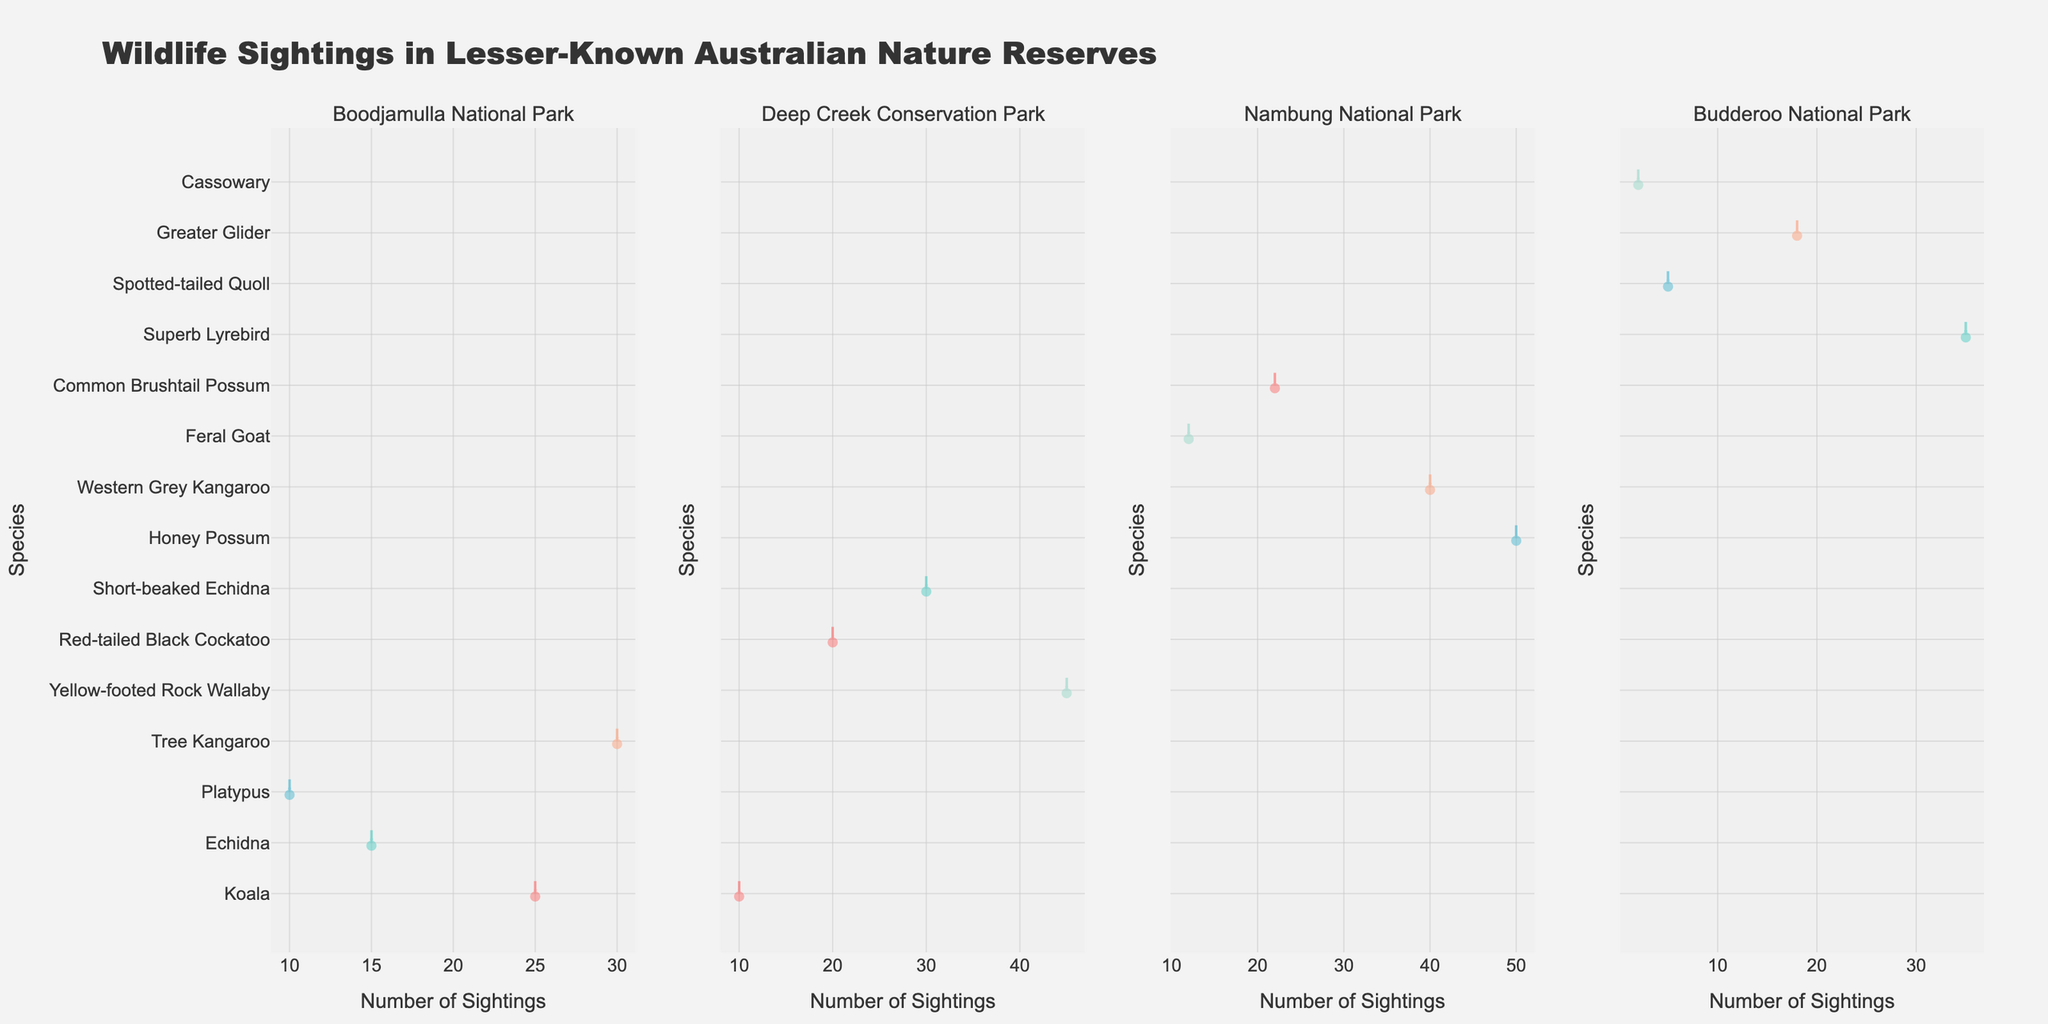What is the title of the plot? The title of the plot is written at the top and it summarizes the content of the figure.
Answer: "Wildlife Sightings in Lesser-Known Australian Nature Reserves" Which nature reserve shows the highest number of Koala sightings? To identify this, look at the violin plots for Koala sightings across all the reserve subplots. Then, check which reserve has the longest spread or highest peak.
Answer: Boodjamulla National Park What is the total number of Echidna sightings across all nature reserves? Sum the individual sightings of Echidnas displayed in each subplot for Boodjamulla National Park and Deep Creek Conservation Park. For Boodjamulla, it's 15 sightings, and for Deep Creek, it's 30 sightings. The total is 15 + 30.
Answer: 45 How do the sighting numbers of the Yellow-footed Rock Wallaby compare to those of the Honey Possum? Look at the violin plots for both species. The length and peak of the Yellow-footed Rock Wallaby's plot correspond to 45, while that of the Honey Possum corresponds to 50. The Honey Possum has slightly higher sightings.
Answer: Honey Possum sightings are higher Which species in Deep Creek Conservation Park has the least number of sightings? Look at all the species within the Deep Creek subplot and identify the species with the shortest violin plot. The Koala has the least sightings.
Answer: Koala What’s the average number of sightings for the Western Grey Kangaroo and the Common Brushtail Possum in Nambung National Park? Sum the sightings of both species and divide by two. Western Grey Kangaroo has 40 sightings, and Common Brushtail Possum has 22. The average is (40 + 22) / 2.
Answer: 31 What is the species with the highest spread in Boodjamulla National Park? The species with the widest violin plot vertically indicates the highest spread or variation in sightings. The Tree Kangaroo shows the highest spread.
Answer: Tree Kangaroo Compare the number of sightings of the Platypus in Boodjamulla National Park to the Cassowary in Budderoo National Park. By checking the lengths of both violin plots, Platypus has 10 sightings and Cassowary has 2 sightings. The Platypus sightings are significantly higher.
Answer: Platypus sightings are higher How do the number of Feral Goat sightings in Nambung National Park compare to the Spotted-tailed Quoll sightings in Budderoo National Park? Look at the violin plots for Feral Goats and Spotted-tailed Quolls in their respective subplots. Feral Goats show 12 sightings, while Spotted-tailed Quolls show 5.
Answer: Feral Goats have more sightings Which reserve has the most diverse range of species based on the number of different species sighted there? Count the number of unique species plotted in each reserve's subplot. Boodjamulla shows 4 different species, Deep Creek 4, Nambung 4, and Budderoo 4. They all show an equal range of species diversity.
Answer: All reserves have similar diversity 